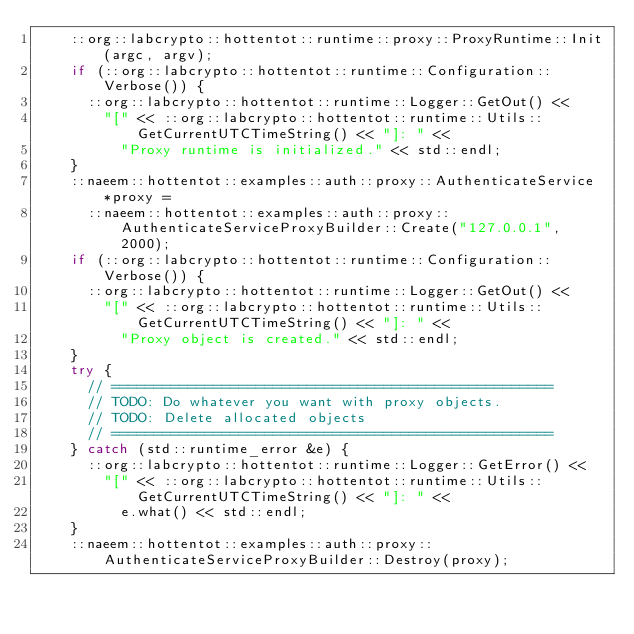Convert code to text. <code><loc_0><loc_0><loc_500><loc_500><_C++_>    ::org::labcrypto::hottentot::runtime::proxy::ProxyRuntime::Init(argc, argv);
    if (::org::labcrypto::hottentot::runtime::Configuration::Verbose()) {
      ::org::labcrypto::hottentot::runtime::Logger::GetOut() << 
        "[" << ::org::labcrypto::hottentot::runtime::Utils::GetCurrentUTCTimeString() << "]: " << 
          "Proxy runtime is initialized." << std::endl;
    }
    ::naeem::hottentot::examples::auth::proxy::AuthenticateService *proxy = 
      ::naeem::hottentot::examples::auth::proxy::AuthenticateServiceProxyBuilder::Create("127.0.0.1", 2000);
    if (::org::labcrypto::hottentot::runtime::Configuration::Verbose()) {
      ::org::labcrypto::hottentot::runtime::Logger::GetOut() << 
        "[" << ::org::labcrypto::hottentot::runtime::Utils::GetCurrentUTCTimeString() << "]: " << 
          "Proxy object is created." << std::endl;
    }
    try {
      // ====================================================
      // TODO: Do whatever you want with proxy objects.
      // TODO: Delete allocated objects
      // ====================================================
    } catch (std::runtime_error &e) {
      ::org::labcrypto::hottentot::runtime::Logger::GetError() << 
        "[" << ::org::labcrypto::hottentot::runtime::Utils::GetCurrentUTCTimeString() << "]: " << 
          e.what() << std::endl;
    }
    ::naeem::hottentot::examples::auth::proxy::AuthenticateServiceProxyBuilder::Destroy(proxy);</code> 